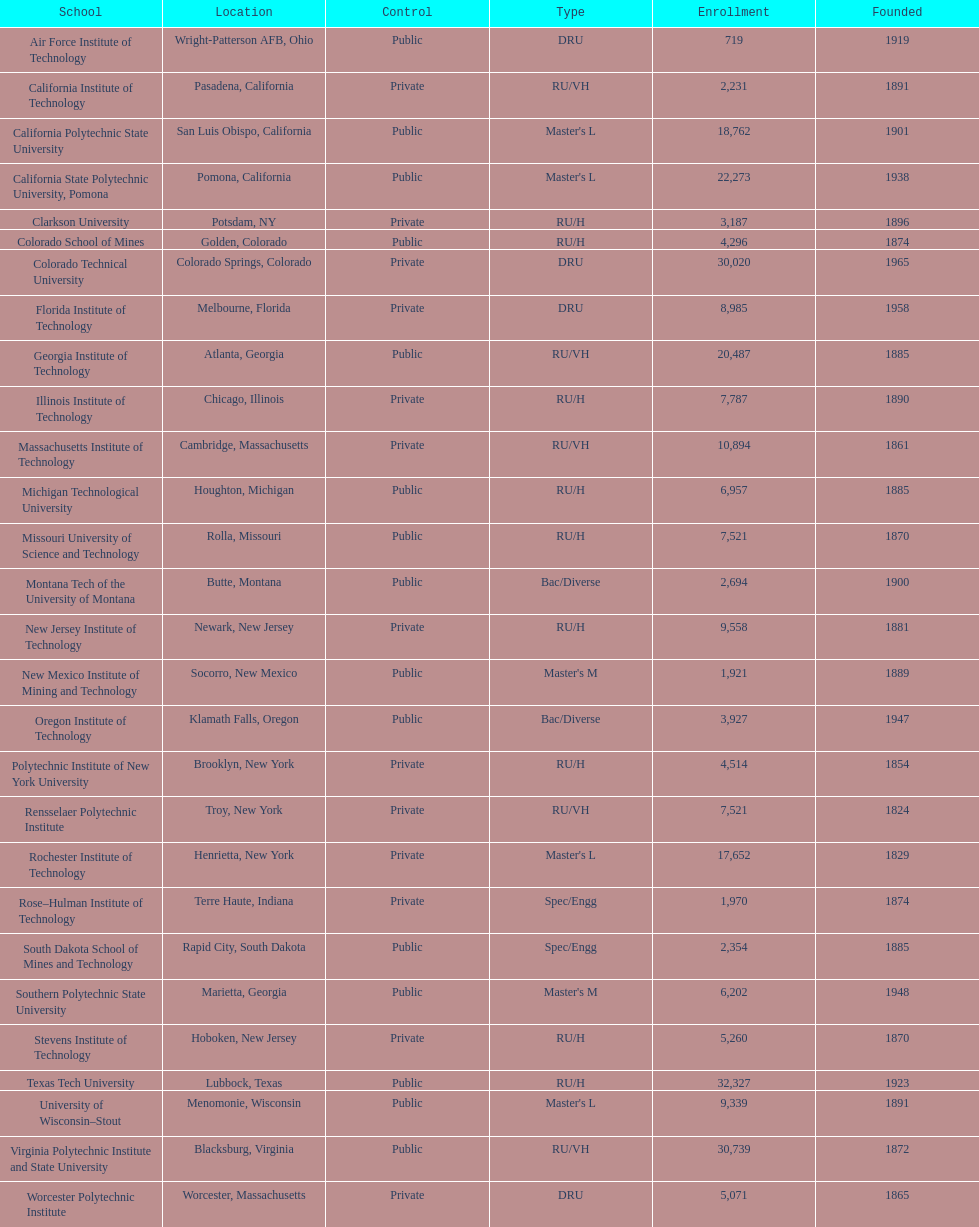How many schools are depicted in the table? 28. 